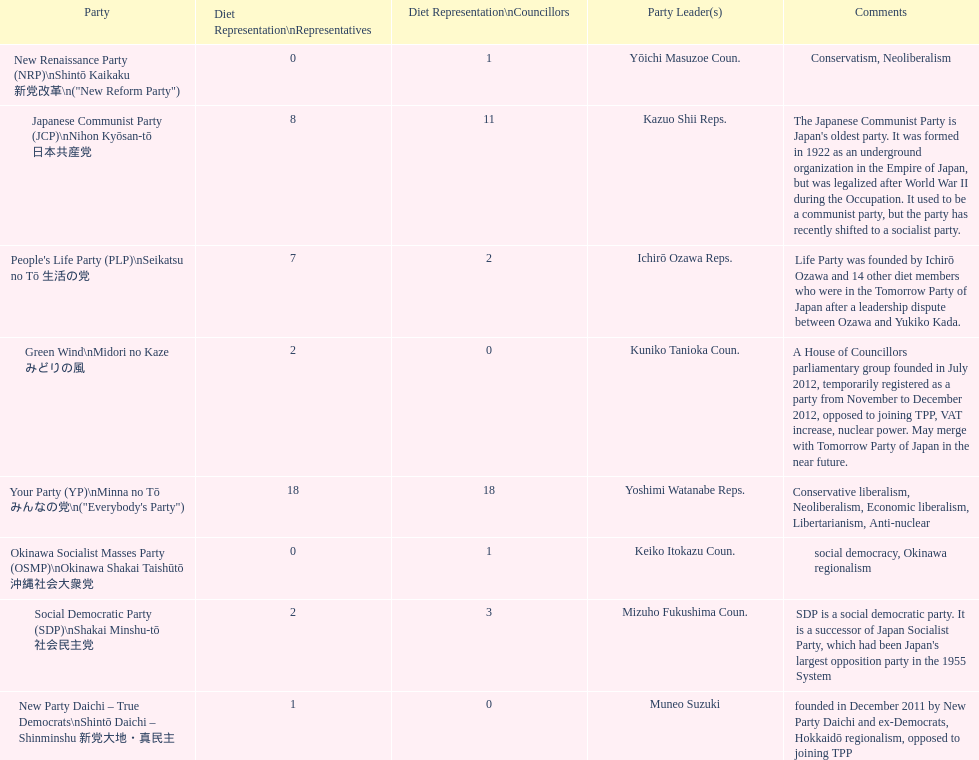What party has the most representatives in the diet representation? Your Party. 